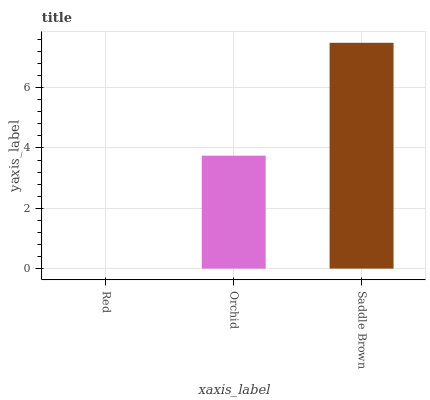Is Red the minimum?
Answer yes or no. Yes. Is Saddle Brown the maximum?
Answer yes or no. Yes. Is Orchid the minimum?
Answer yes or no. No. Is Orchid the maximum?
Answer yes or no. No. Is Orchid greater than Red?
Answer yes or no. Yes. Is Red less than Orchid?
Answer yes or no. Yes. Is Red greater than Orchid?
Answer yes or no. No. Is Orchid less than Red?
Answer yes or no. No. Is Orchid the high median?
Answer yes or no. Yes. Is Orchid the low median?
Answer yes or no. Yes. Is Red the high median?
Answer yes or no. No. Is Saddle Brown the low median?
Answer yes or no. No. 